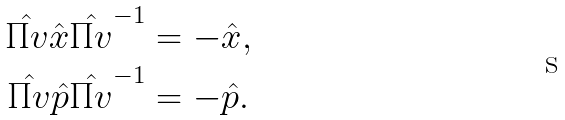<formula> <loc_0><loc_0><loc_500><loc_500>\hat { \Pi v } \hat { x } \hat { \Pi v } ^ { - 1 } & = - \hat { x } , \\ \hat { \Pi v } \hat { p } \hat { \Pi v } ^ { - 1 } & = - \hat { p } .</formula> 